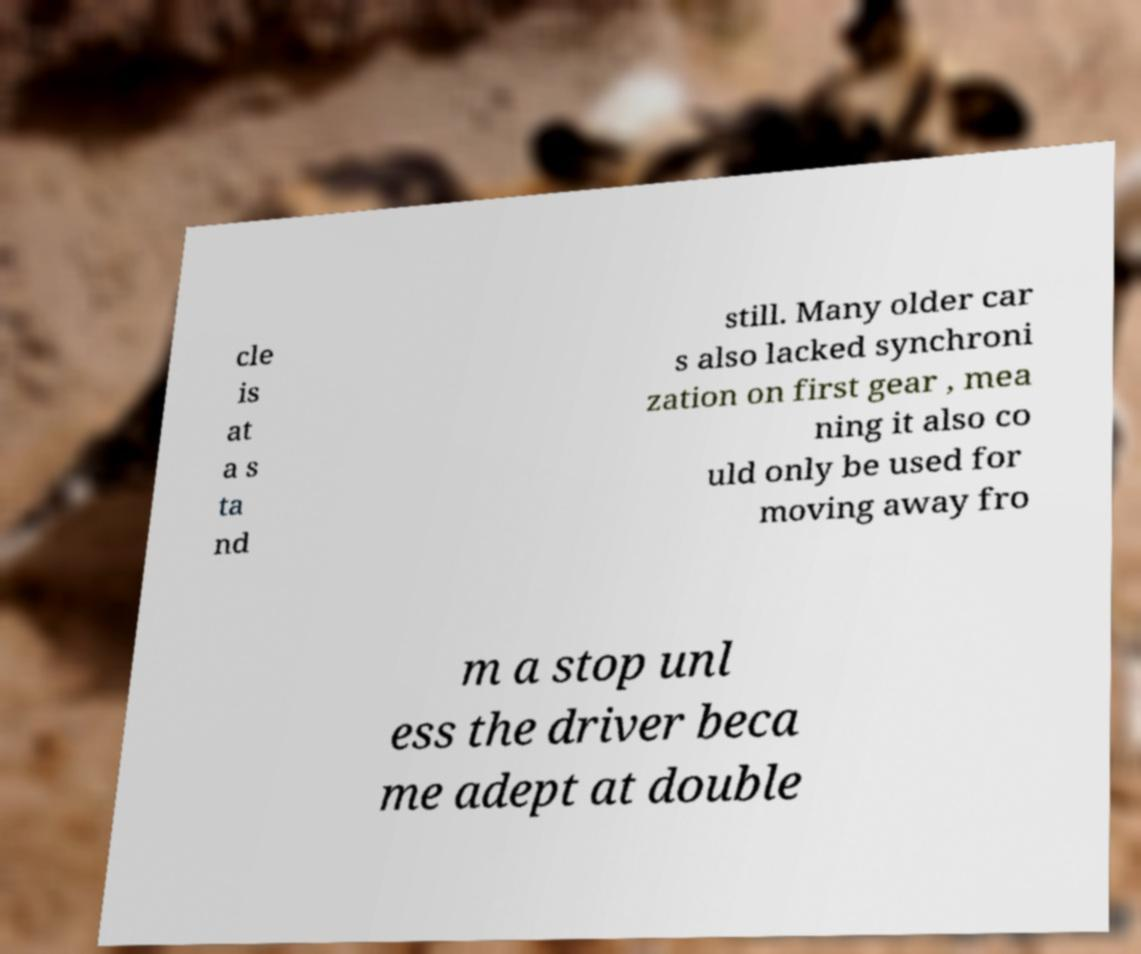Please identify and transcribe the text found in this image. cle is at a s ta nd still. Many older car s also lacked synchroni zation on first gear , mea ning it also co uld only be used for moving away fro m a stop unl ess the driver beca me adept at double 